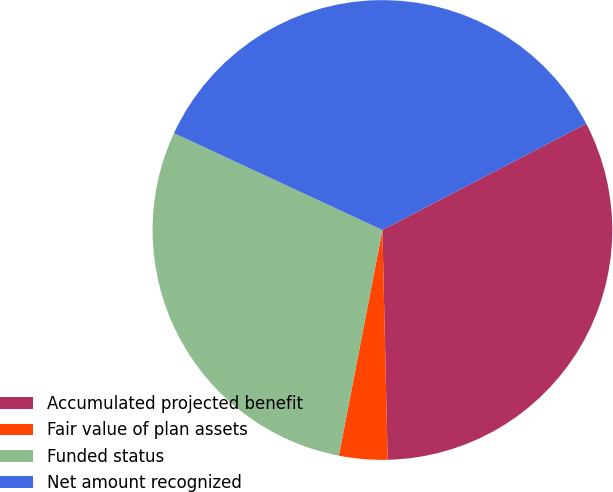<chart> <loc_0><loc_0><loc_500><loc_500><pie_chart><fcel>Accumulated projected benefit<fcel>Fair value of plan assets<fcel>Funded status<fcel>Net amount recognized<nl><fcel>32.29%<fcel>3.4%<fcel>28.89%<fcel>35.43%<nl></chart> 